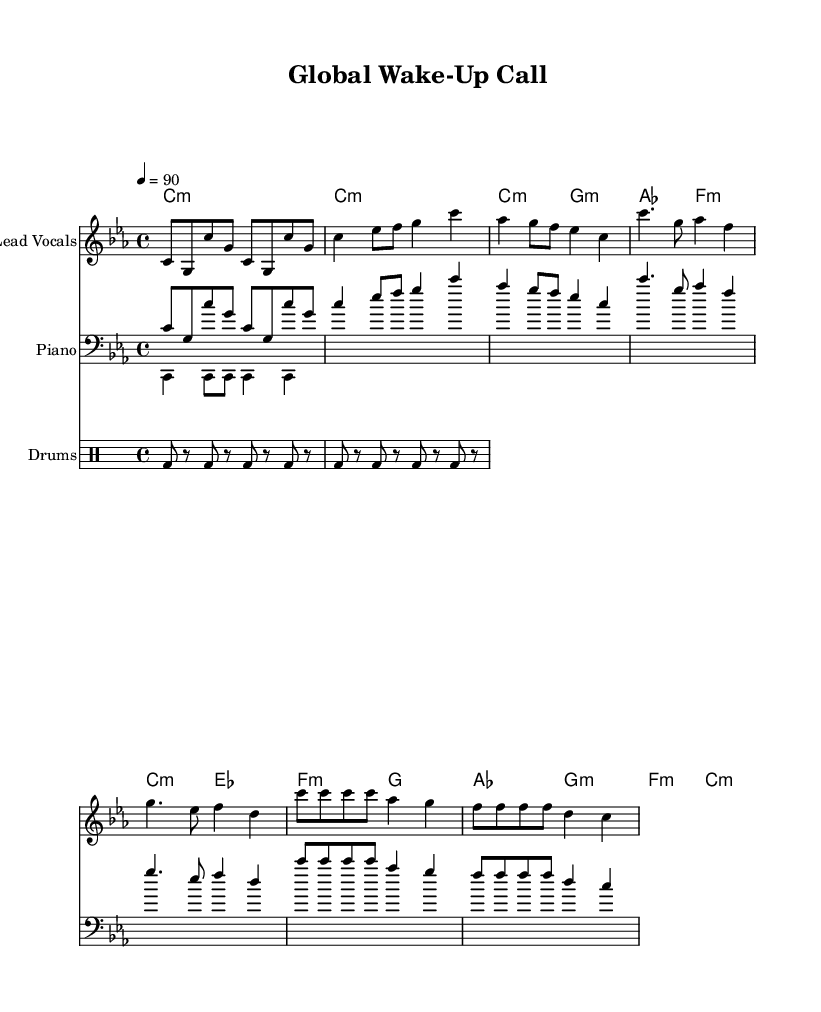what is the key signature of this music? The key signature indicated in the sheet music is C minor, which is represented by three flat symbols (B flat, E flat, and A flat).
Answer: C minor what is the time signature of this music? The time signature shown in the sheet music is 4/4, meaning there are four beats in each measure and the quarter note gets one beat.
Answer: 4/4 what is the tempo marking of this music? The sheet music states a tempo of 90 beats per minute, indicated by the marking "4 = 90".
Answer: 90 how many measures are in the verse section? In the sheet music, the verse section contains 4 measures, as indicated by the grouping of notes.
Answer: 4 what chords are used in the chorus? The chords listed in the sheet music for the chorus are C minor, E flat major, F minor, and G minor, which create a progression fitting for the rap style.
Answer: C minor, E flat major, F minor, G minor what rhythmic pattern is used in the drum section? The drum pattern specified in the sheet music consists of a bass drum played in a repeated pattern over four beats, creating a driving rhythm suitable for rap music.
Answer: Bass drum pattern how does the melody change in the bridge compared to the verse? In the bridge, the melody has a more repetitive and slower pace compared to the verse, highlighting a shift in emotional intensity and dynamics which is common in rap structure.
Answer: More repetitive and slower 